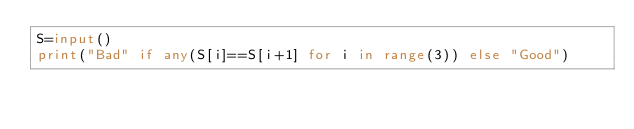<code> <loc_0><loc_0><loc_500><loc_500><_Python_>S=input()
print("Bad" if any(S[i]==S[i+1] for i in range(3)) else "Good")</code> 